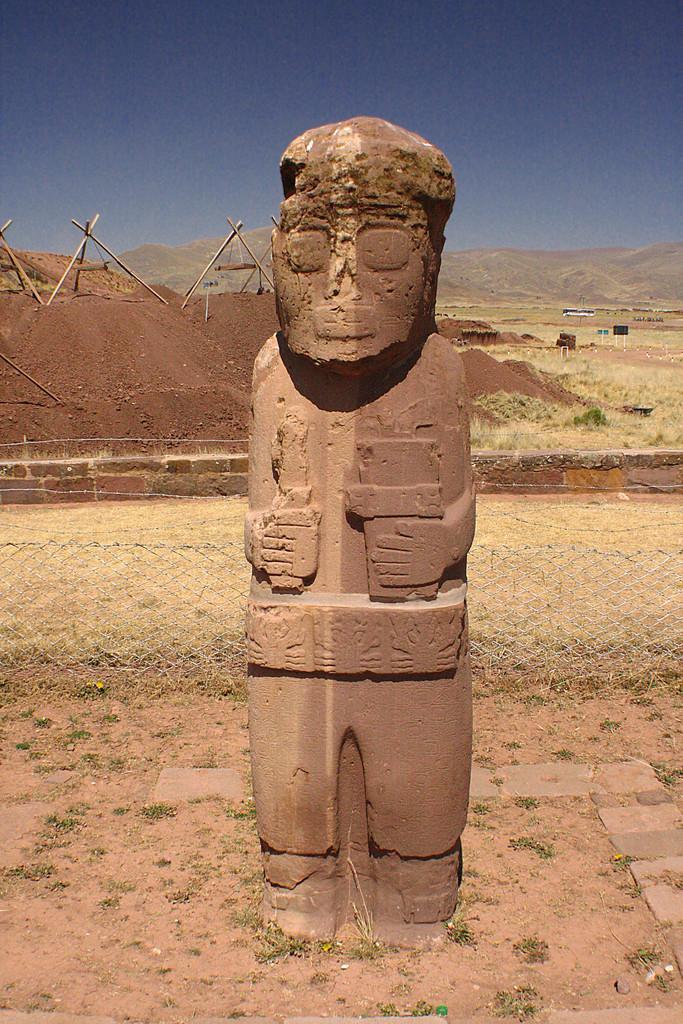Please provide a concise description of this image. In this image there is a depiction of a person, behind that there is a net fence and there are a few sticks arranged on the surface of the sand. In the background there are mountains and the sky. 